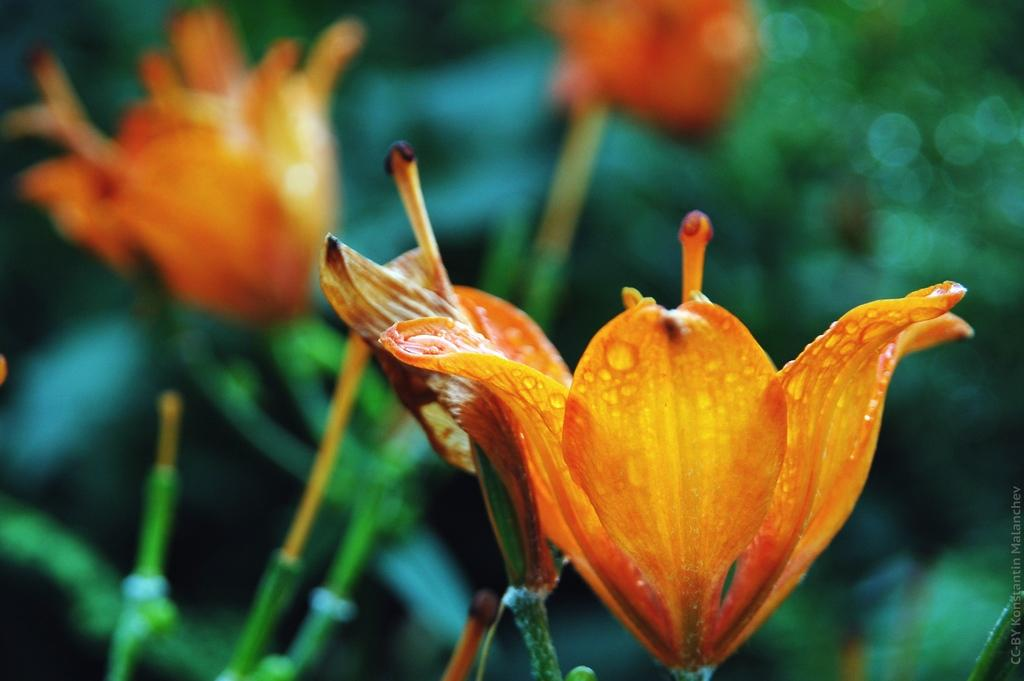What is present in the image? There are flowers in the image. How would you describe the background of the image? The background of the image is blurred. What color tone is dominant in the image? The image has a green color tone. Can you hear the rhythm of the balloon in the image? There is no balloon present in the image, and therefore no rhythm to be heard. 